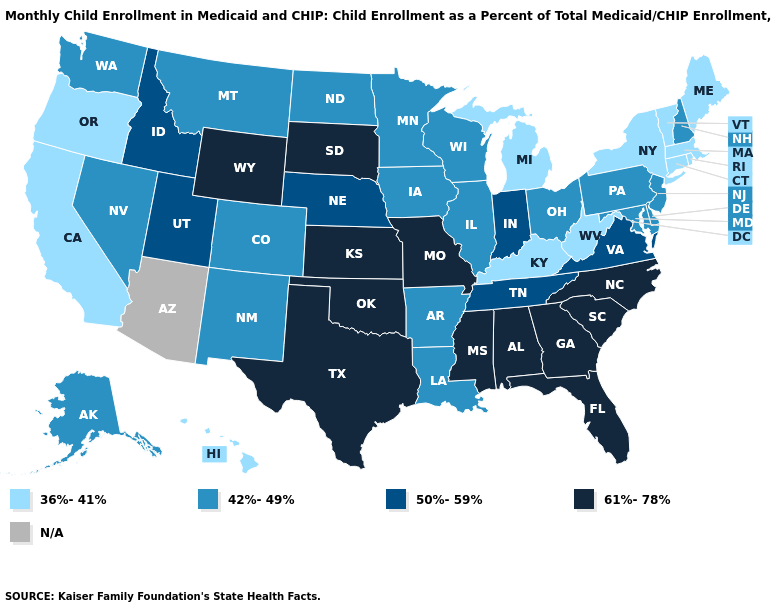What is the value of Montana?
Keep it brief. 42%-49%. What is the lowest value in the USA?
Be succinct. 36%-41%. Name the states that have a value in the range 61%-78%?
Give a very brief answer. Alabama, Florida, Georgia, Kansas, Mississippi, Missouri, North Carolina, Oklahoma, South Carolina, South Dakota, Texas, Wyoming. Which states hav the highest value in the MidWest?
Keep it brief. Kansas, Missouri, South Dakota. Among the states that border Georgia , which have the lowest value?
Short answer required. Tennessee. Does the first symbol in the legend represent the smallest category?
Be succinct. Yes. What is the value of Alaska?
Concise answer only. 42%-49%. Which states have the highest value in the USA?
Short answer required. Alabama, Florida, Georgia, Kansas, Mississippi, Missouri, North Carolina, Oklahoma, South Carolina, South Dakota, Texas, Wyoming. Among the states that border Connecticut , which have the highest value?
Give a very brief answer. Massachusetts, New York, Rhode Island. Does the map have missing data?
Write a very short answer. Yes. What is the value of Wisconsin?
Quick response, please. 42%-49%. 